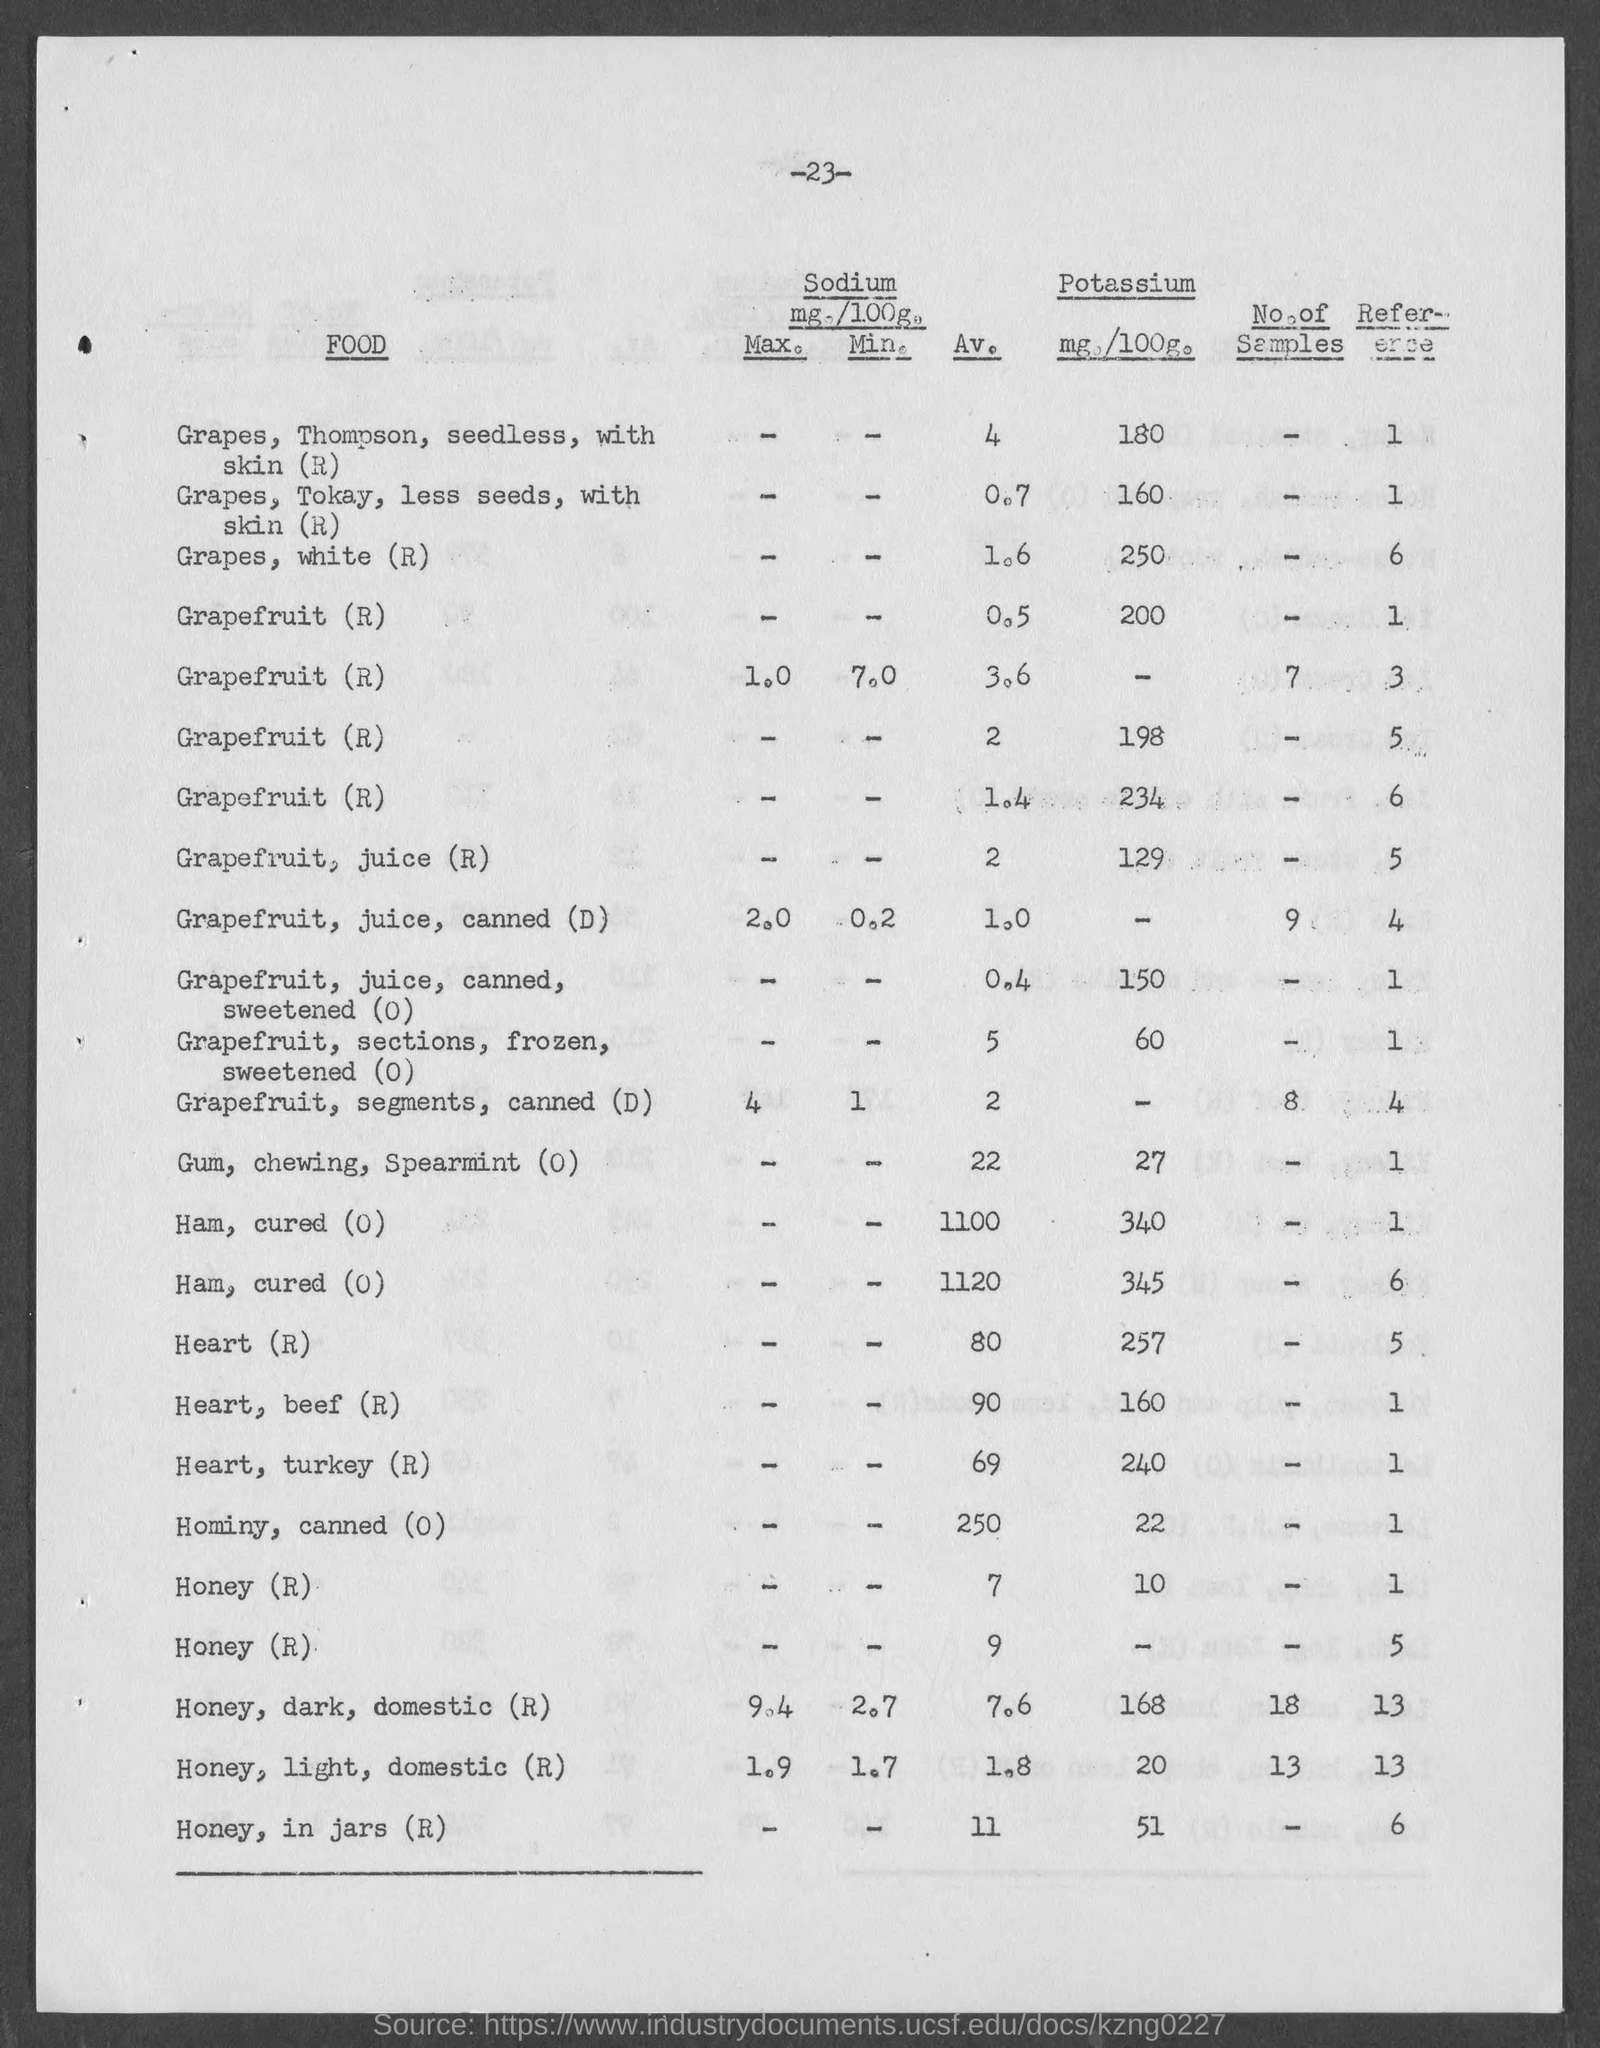List a handful of essential elements in this visual. There is potassium in Heart(R). The amount of potassium in Heart(R) is 257. The average sodium content in spearmint chewing gum is 0 milligrams per serving. The potassium content in spearmint chewing gum is 0 milligrams per serving. The average sodium level in a healthy human heart is 80 milliequivalents per liter. The average sodium content in white grapes is 1.6 milligrams per serving. 